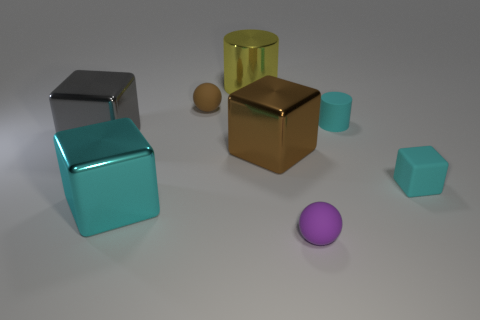Do the cyan thing on the left side of the purple matte object and the tiny brown rubber object have the same size?
Your answer should be very brief. No. Is the number of large gray metal cubes that are to the left of the cyan metal thing greater than the number of brown metal balls?
Give a very brief answer. Yes. There is a big metal cube that is on the right side of the brown matte sphere; how many metallic objects are to the left of it?
Offer a very short reply. 3. Is the number of gray objects on the right side of the large yellow thing less than the number of big brown objects?
Your answer should be very brief. Yes. There is a big thing in front of the brown object on the right side of the yellow shiny cylinder; are there any metal blocks behind it?
Provide a succinct answer. Yes. Are the yellow cylinder and the brown thing in front of the brown matte thing made of the same material?
Offer a very short reply. Yes. What color is the tiny rubber sphere that is to the left of the tiny matte ball that is in front of the brown rubber thing?
Make the answer very short. Brown. Are there any large cylinders that have the same color as the small cylinder?
Offer a very short reply. No. There is a cyan matte thing on the left side of the cyan block on the right side of the rubber ball that is in front of the large cyan shiny cube; what is its size?
Keep it short and to the point. Small. There is a tiny purple rubber object; is its shape the same as the small rubber object on the left side of the big metal cylinder?
Provide a succinct answer. Yes. 